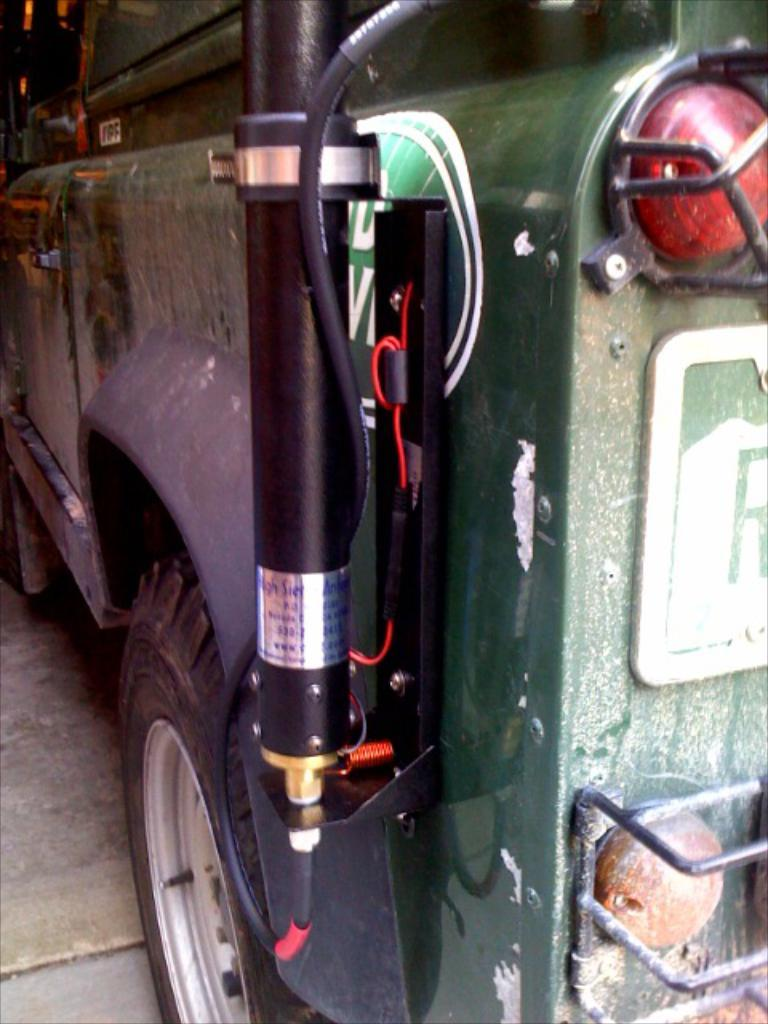What type of object is the main subject in the image? The image contains a vehicle. What specific features can be observed on the vehicle? The vehicle has tail lights, a wheel, and a pipe attached to it. What is the color of the vehicle? The vehicle is dark green in color. What type of toothbrush is hanging from the pipe attached to the vehicle? There is no toothbrush present in the image; it only features a vehicle with tail lights, a wheel, and a pipe attached to it. 